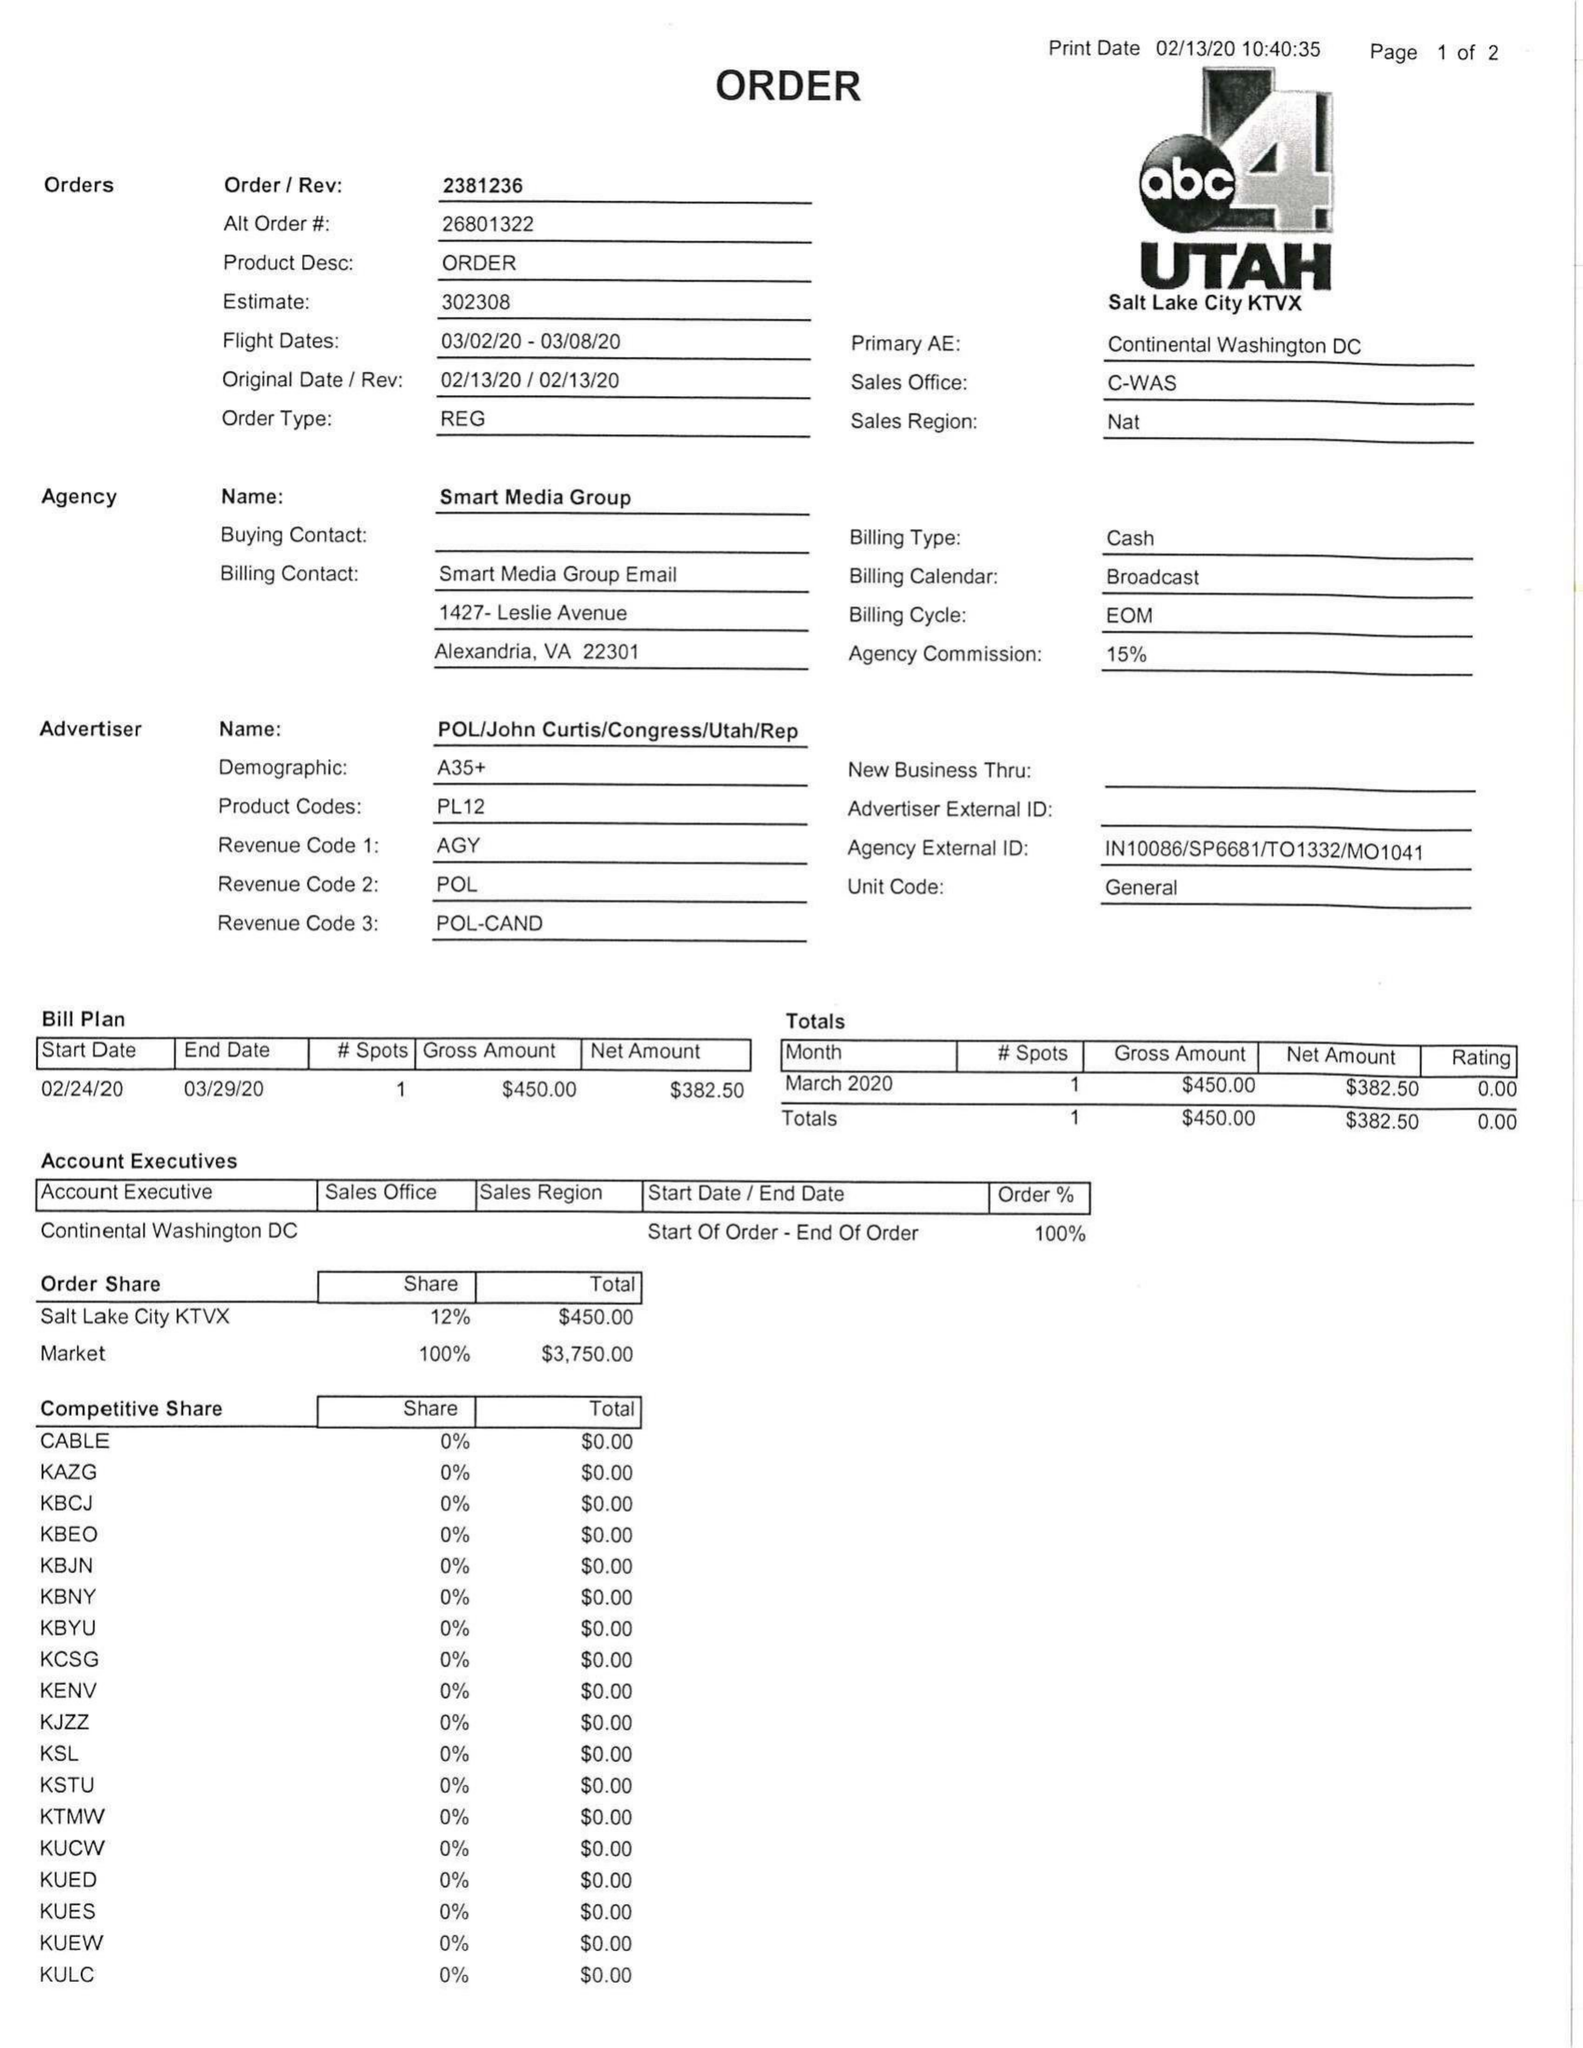What is the value for the flight_to?
Answer the question using a single word or phrase. 03/08/20 